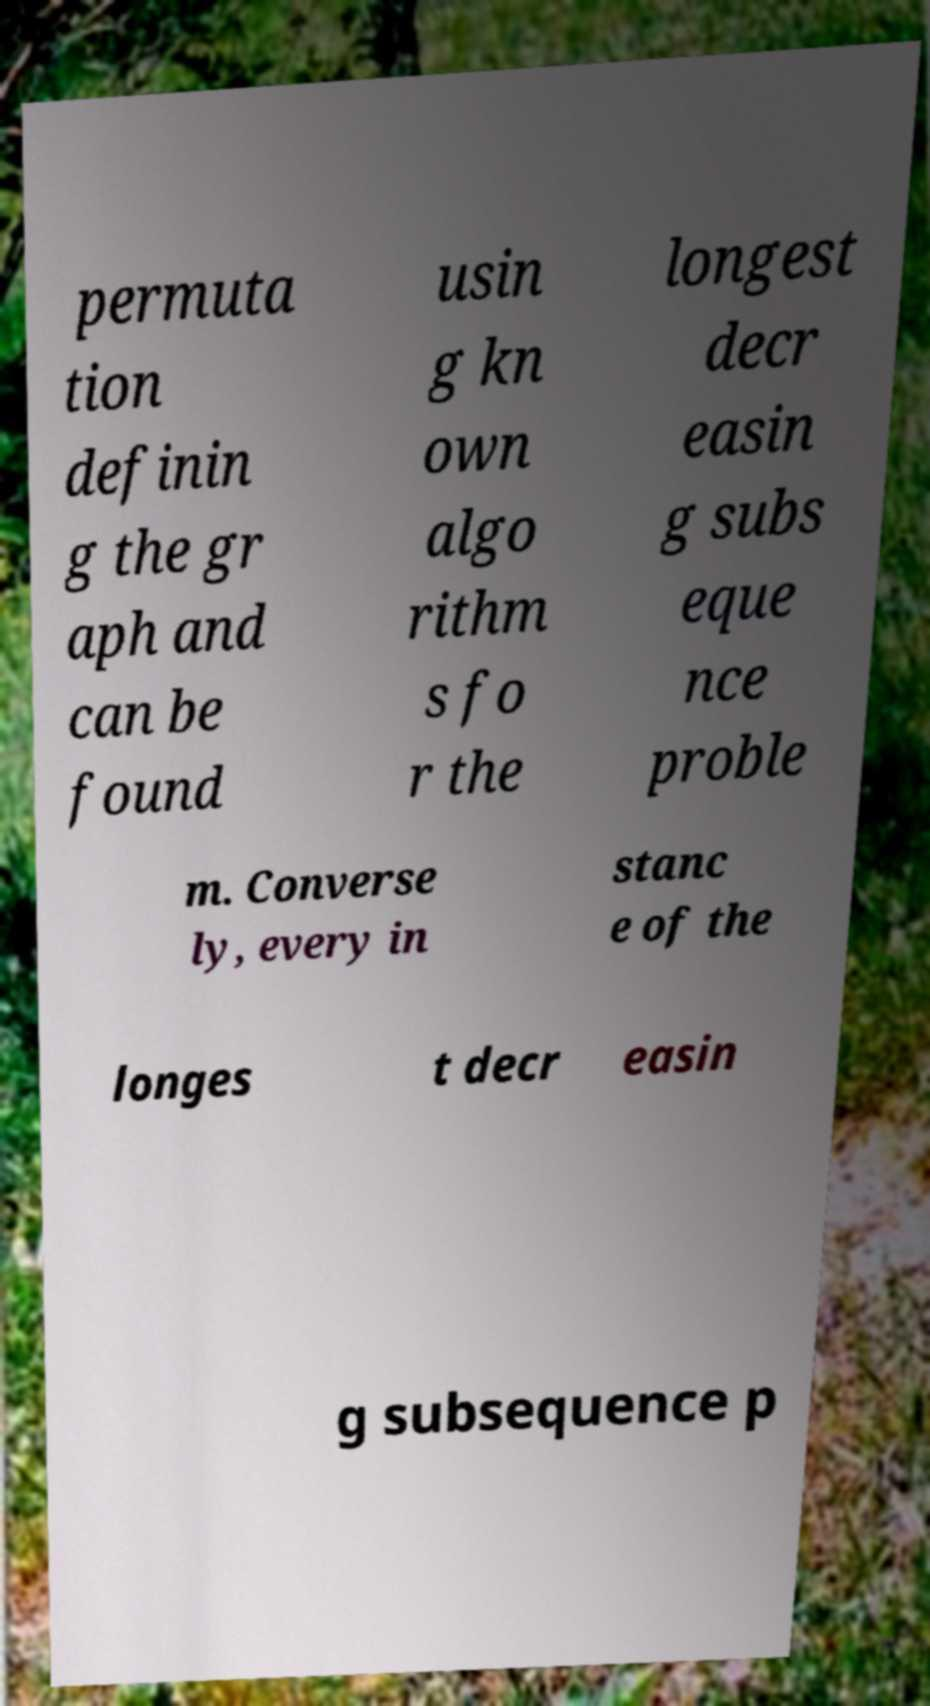There's text embedded in this image that I need extracted. Can you transcribe it verbatim? permuta tion definin g the gr aph and can be found usin g kn own algo rithm s fo r the longest decr easin g subs eque nce proble m. Converse ly, every in stanc e of the longes t decr easin g subsequence p 